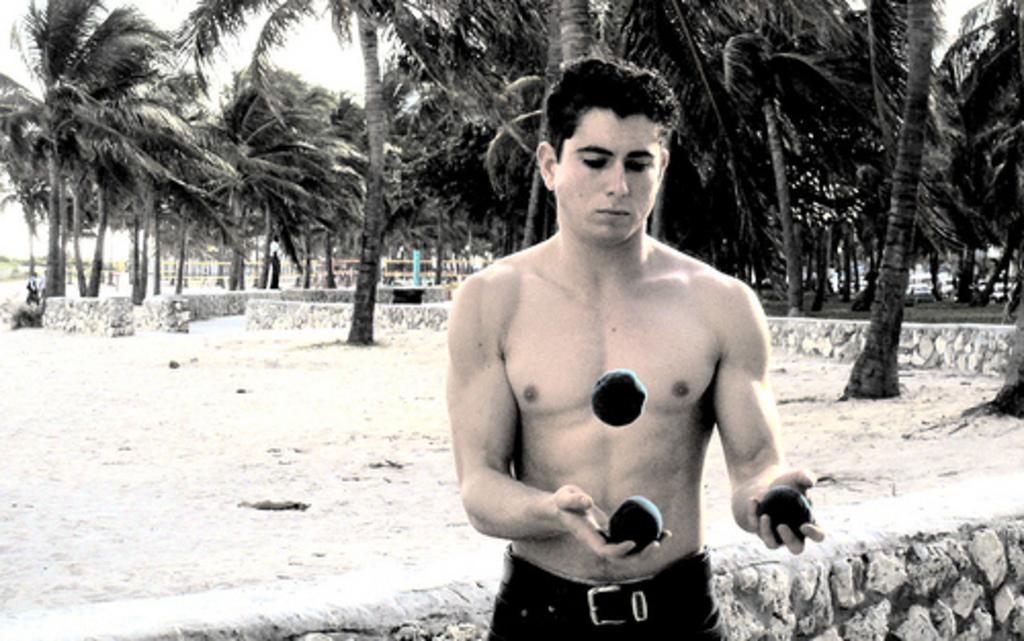Could you give a brief overview of what you see in this image? In the image we can see a man standing, wearing trouser and he is playing with an object which is in circular shape. This is a sand, trees and a sky. 